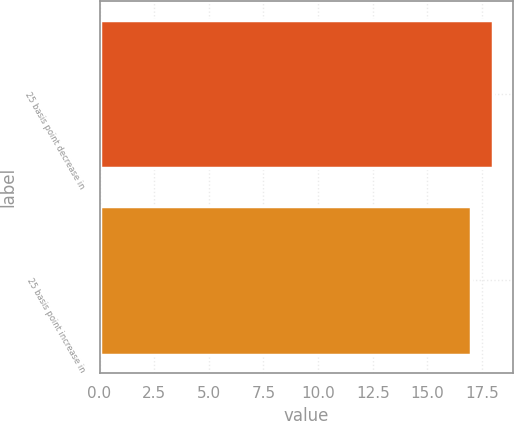Convert chart to OTSL. <chart><loc_0><loc_0><loc_500><loc_500><bar_chart><fcel>25 basis point decrease in<fcel>25 basis point increase in<nl><fcel>18<fcel>17<nl></chart> 